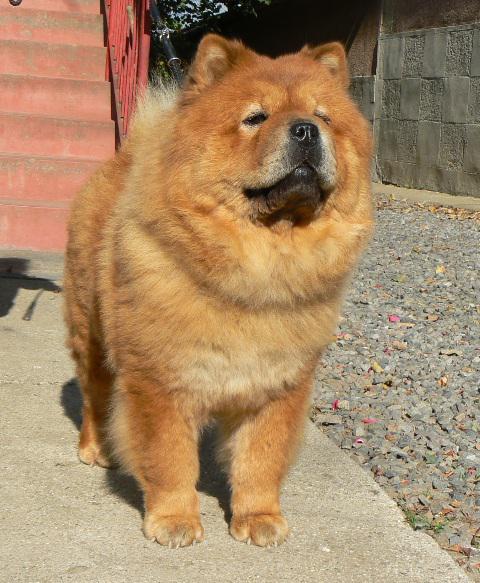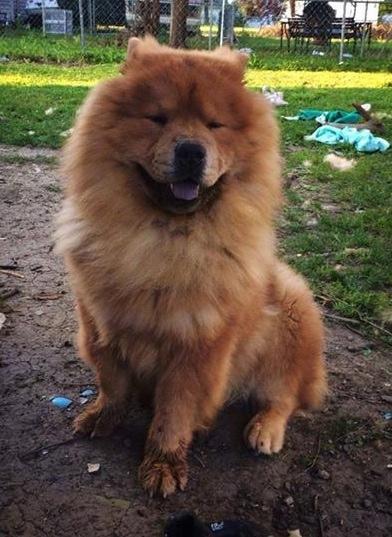The first image is the image on the left, the second image is the image on the right. For the images shown, is this caption "One dog is sitting and one is standing." true? Answer yes or no. Yes. The first image is the image on the left, the second image is the image on the right. Analyze the images presented: Is the assertion "The right image contains one chow dog attached to a leash." valid? Answer yes or no. No. 